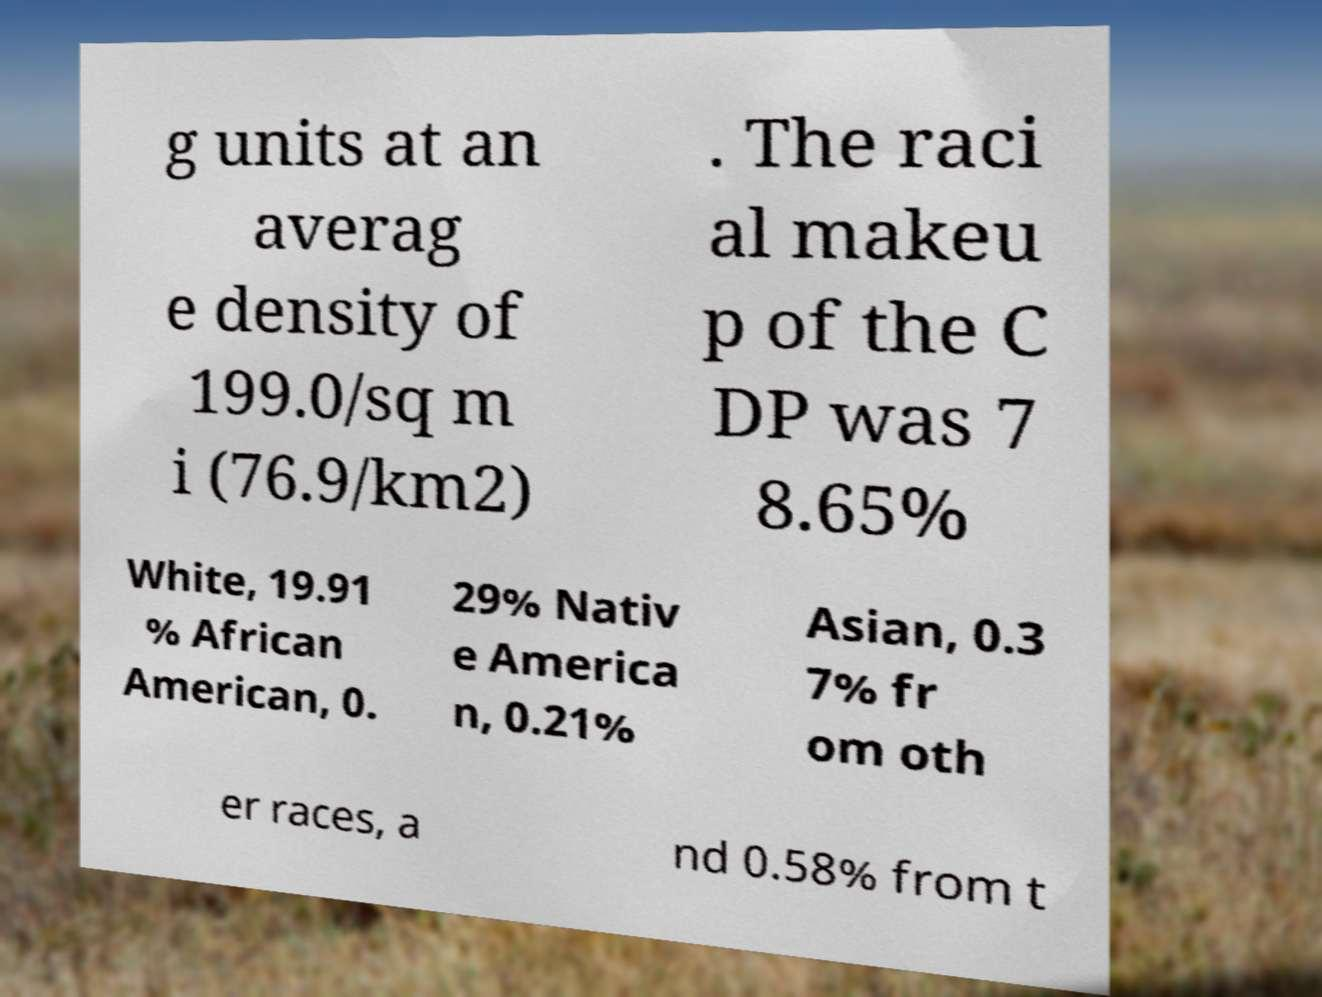For documentation purposes, I need the text within this image transcribed. Could you provide that? g units at an averag e density of 199.0/sq m i (76.9/km2) . The raci al makeu p of the C DP was 7 8.65% White, 19.91 % African American, 0. 29% Nativ e America n, 0.21% Asian, 0.3 7% fr om oth er races, a nd 0.58% from t 